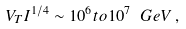<formula> <loc_0><loc_0><loc_500><loc_500>V _ { T } I ^ { 1 / 4 } \sim 1 0 ^ { 6 } t o 1 0 ^ { 7 } \ G e V \, ,</formula> 